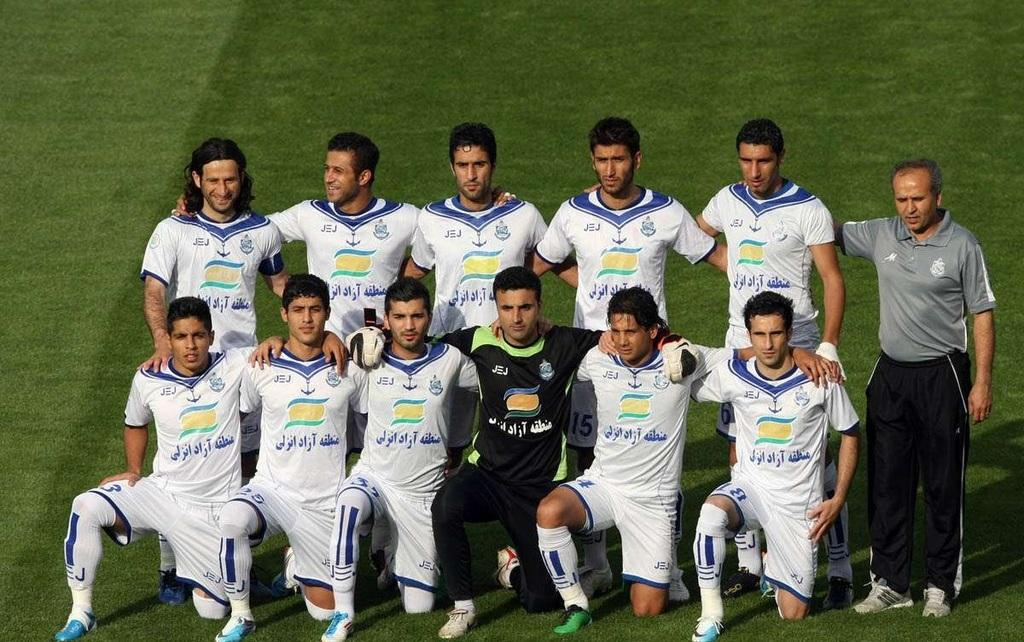What type of vegetation is visible in the image? There is grass in the image. What can be seen in the front of the image? There are people standing in the front of the image. What type of snow can be seen falling in the image? There is no snow present in the image; it features grass and people. What type of approval is required for the title of the image? There is no title associated with the image, so the concept of approval for a title is not applicable. 